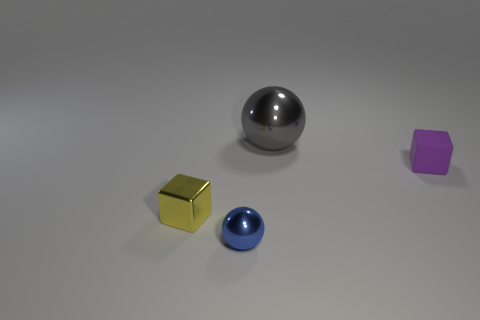What is the size of the cube left of the small rubber cube?
Offer a very short reply. Small. Are there any things of the same color as the tiny ball?
Offer a very short reply. No. There is a ball that is in front of the gray metal ball; is it the same size as the purple rubber thing?
Provide a short and direct response. Yes. The matte thing has what color?
Provide a short and direct response. Purple. The cube in front of the cube behind the tiny yellow object is what color?
Your answer should be very brief. Yellow. Are there any yellow objects that have the same material as the gray thing?
Offer a terse response. Yes. The tiny object in front of the small cube that is on the left side of the purple rubber block is made of what material?
Your answer should be compact. Metal. How many purple objects are the same shape as the tiny yellow object?
Provide a short and direct response. 1. The purple thing has what shape?
Provide a succinct answer. Cube. Are there fewer small purple cubes than large purple matte balls?
Give a very brief answer. No. 